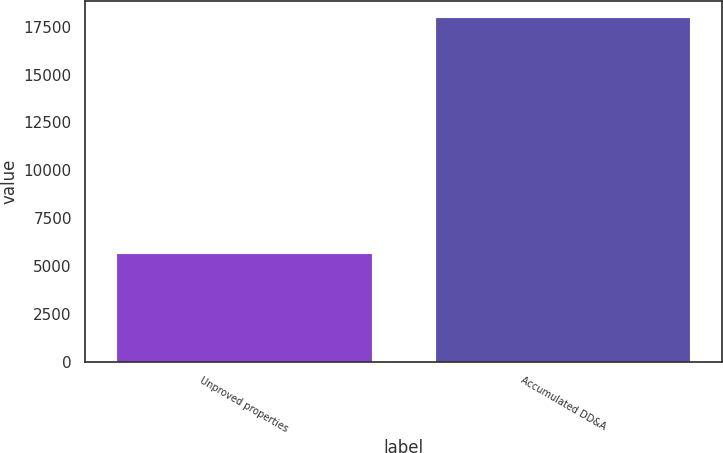Convert chart to OTSL. <chart><loc_0><loc_0><loc_500><loc_500><bar_chart><fcel>Unproved properties<fcel>Accumulated DD&A<nl><fcel>5641<fcel>17968<nl></chart> 